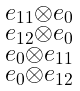<formula> <loc_0><loc_0><loc_500><loc_500>\begin{smallmatrix} e _ { 1 1 } \otimes e _ { 0 } \\ e _ { 1 2 } \otimes e _ { 0 } \\ e _ { 0 } \otimes e _ { 1 1 } \\ e _ { 0 } \otimes e _ { 1 2 } \end{smallmatrix}</formula> 